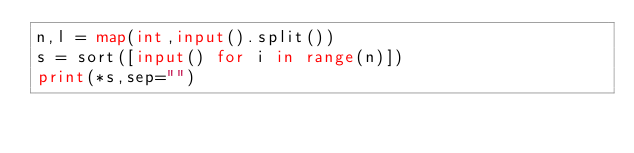<code> <loc_0><loc_0><loc_500><loc_500><_Python_>n,l = map(int,input().split())
s = sort([input() for i in range(n)])
print(*s,sep="")</code> 